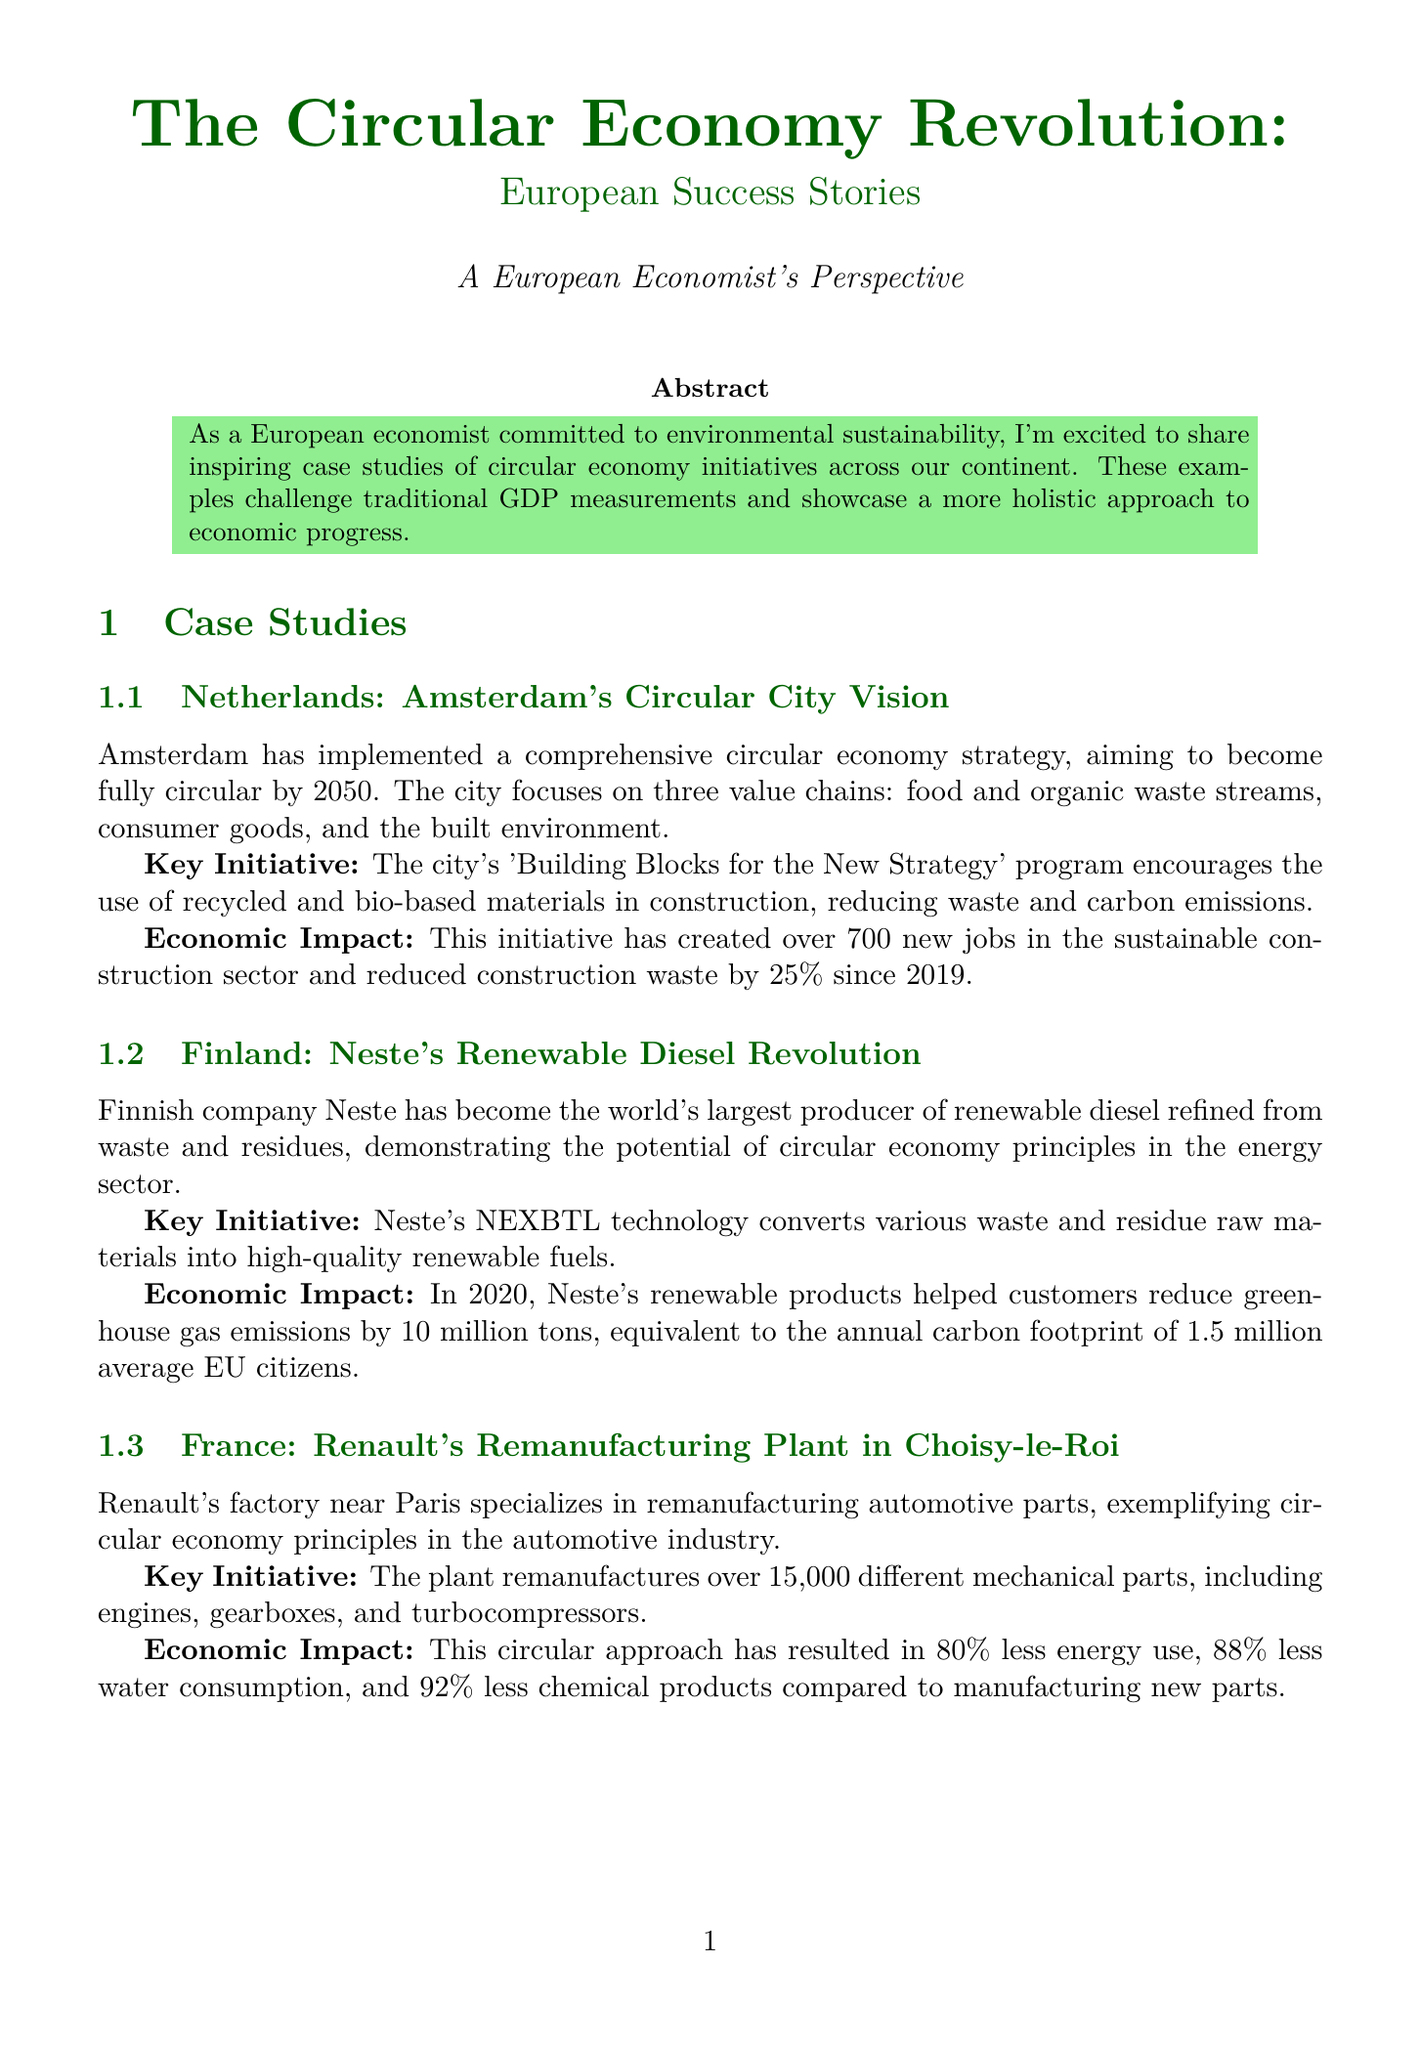What is the main goal of Amsterdam's circular economy strategy? The document states that Amsterdam aims to become fully circular by 2050.
Answer: Fully circular by 2050 How many new jobs has Amsterdam's initiative created? The document indicates that the initiative has created over 700 new jobs in the sustainable construction sector.
Answer: Over 700 What technology does Neste use to produce renewable diesel? The document specifies that Neste's technology is called NEXBTL, which converts waste and residue raw materials into renewable fuels.
Answer: NEXBTL What percentage less water does Renault's plant use compared to manufacturing new parts? The document states that Renault's approach has resulted in 88% less water consumption compared to new parts manufacturing.
Answer: 88% What is the proposed measure to enhance circular economy education? The document recommends introducing mandatory circular economy education in schools and universities.
Answer: Mandatory circular economy education in schools and universities What should be included in economic assessments according to the expert analysis? The document suggests incorporating metrics such as resource productivity, waste reduction, and carbon emissions avoidance.
Answer: Resource productivity, waste reduction, and carbon emissions avoidance What is the key initiative of Renault's remanufacturing plant? The document mentions that the plant remanufactures over 15,000 different mechanical parts.
Answer: Over 15,000 different mechanical parts In which country is Neste located? The document states that Neste is a Finnish company.
Answer: Finland 